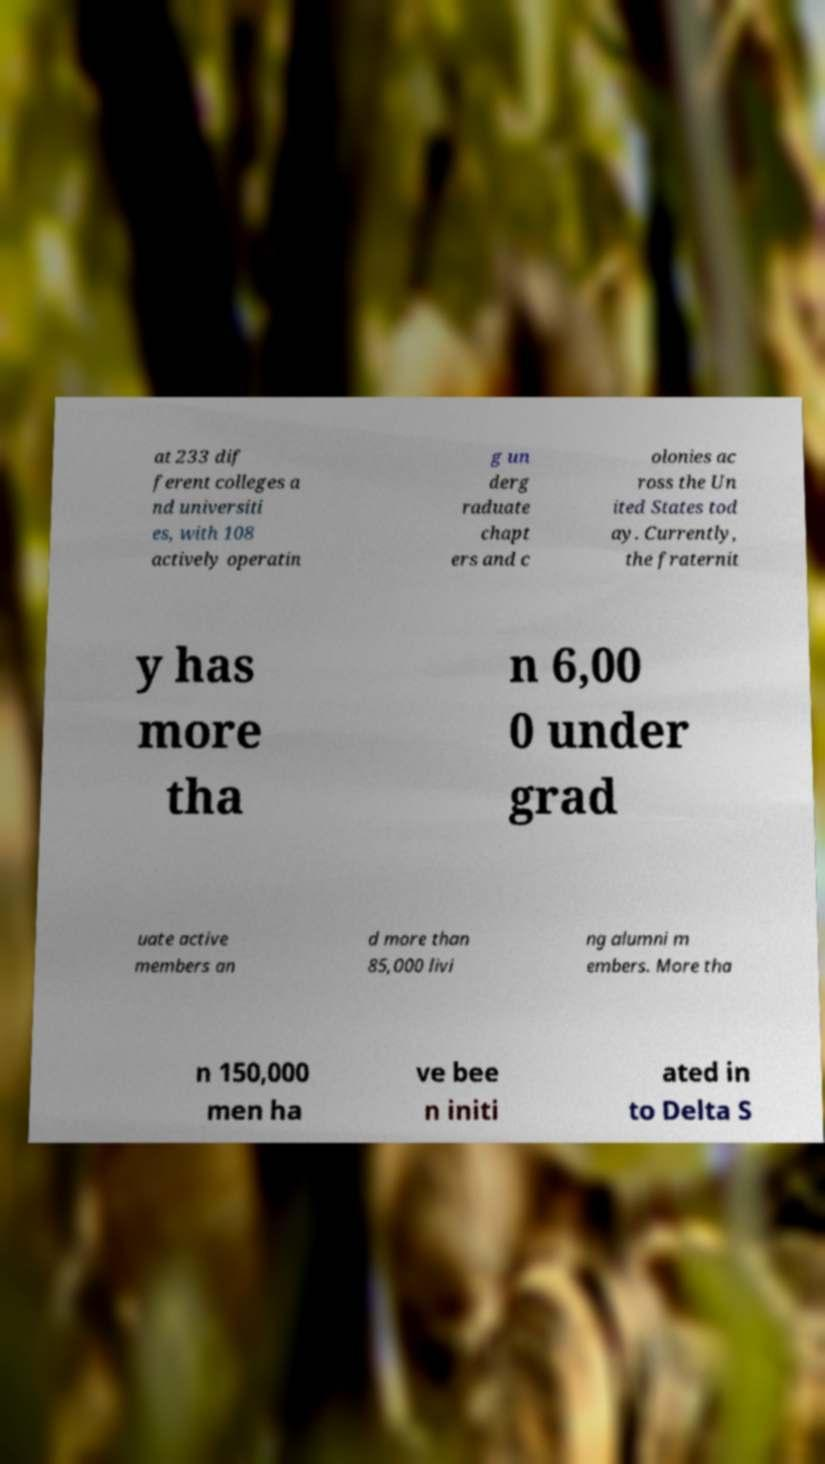Could you assist in decoding the text presented in this image and type it out clearly? at 233 dif ferent colleges a nd universiti es, with 108 actively operatin g un derg raduate chapt ers and c olonies ac ross the Un ited States tod ay. Currently, the fraternit y has more tha n 6,00 0 under grad uate active members an d more than 85,000 livi ng alumni m embers. More tha n 150,000 men ha ve bee n initi ated in to Delta S 